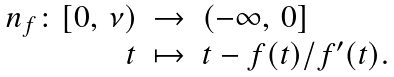<formula> <loc_0><loc_0><loc_500><loc_500>\begin{array} { r c l } n _ { f } \colon [ 0 , \, \nu ) & \to & ( - \infty , \, 0 ] \\ t & \mapsto & t - f ( t ) / f ^ { \prime } ( t ) . \end{array}</formula> 